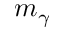<formula> <loc_0><loc_0><loc_500><loc_500>m _ { \gamma }</formula> 